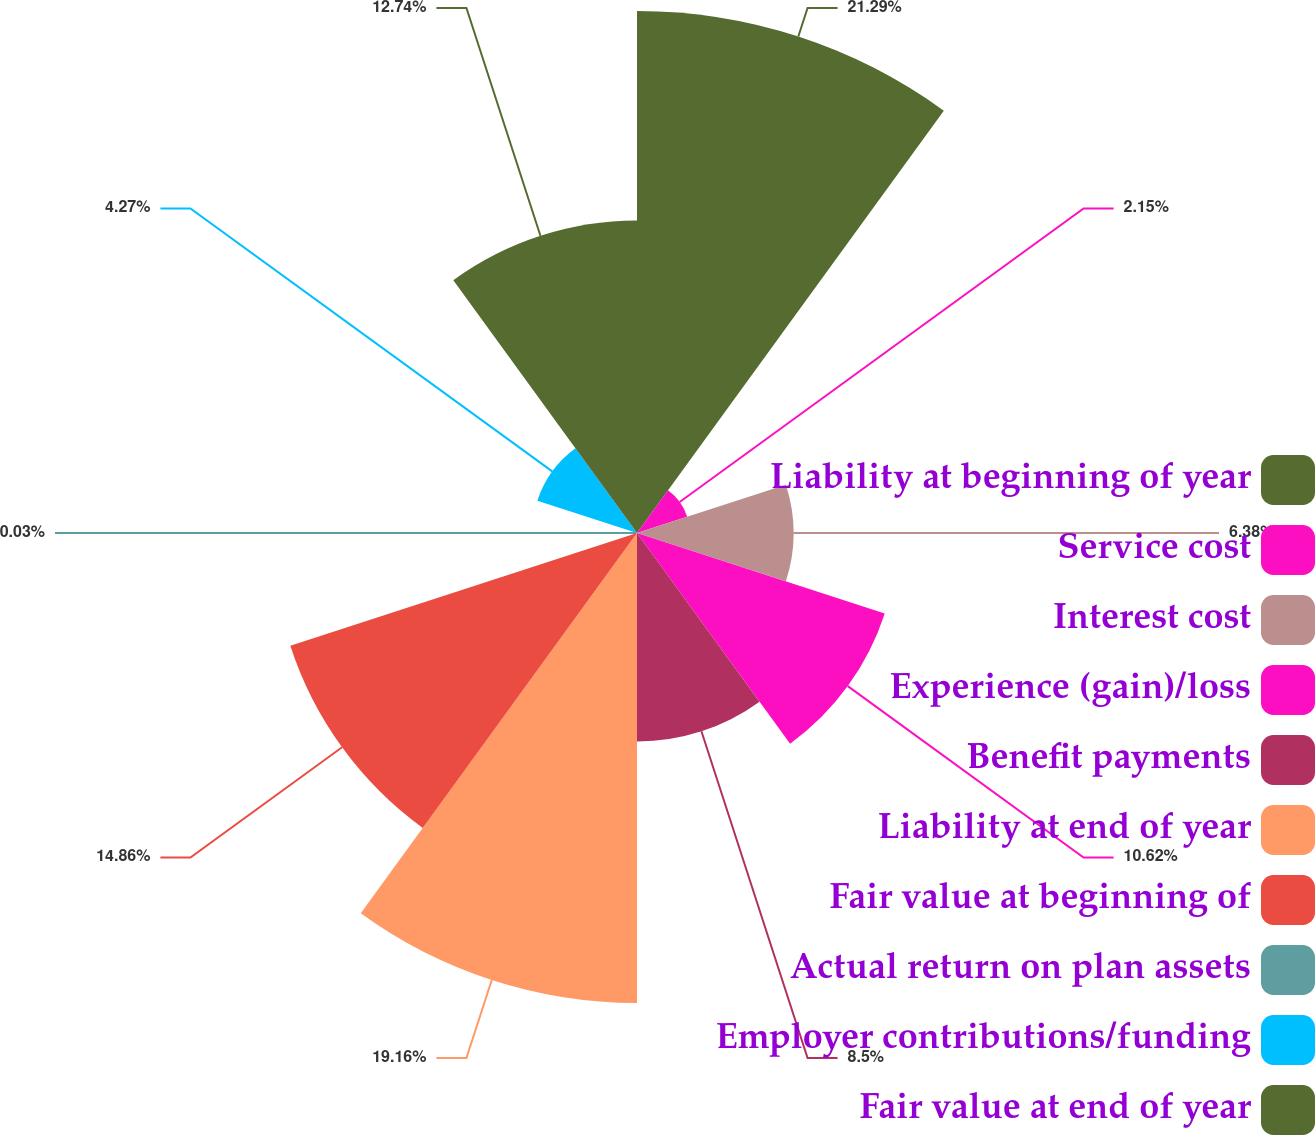Convert chart. <chart><loc_0><loc_0><loc_500><loc_500><pie_chart><fcel>Liability at beginning of year<fcel>Service cost<fcel>Interest cost<fcel>Experience (gain)/loss<fcel>Benefit payments<fcel>Liability at end of year<fcel>Fair value at beginning of<fcel>Actual return on plan assets<fcel>Employer contributions/funding<fcel>Fair value at end of year<nl><fcel>21.28%<fcel>2.15%<fcel>6.38%<fcel>10.62%<fcel>8.5%<fcel>19.16%<fcel>14.86%<fcel>0.03%<fcel>4.27%<fcel>12.74%<nl></chart> 